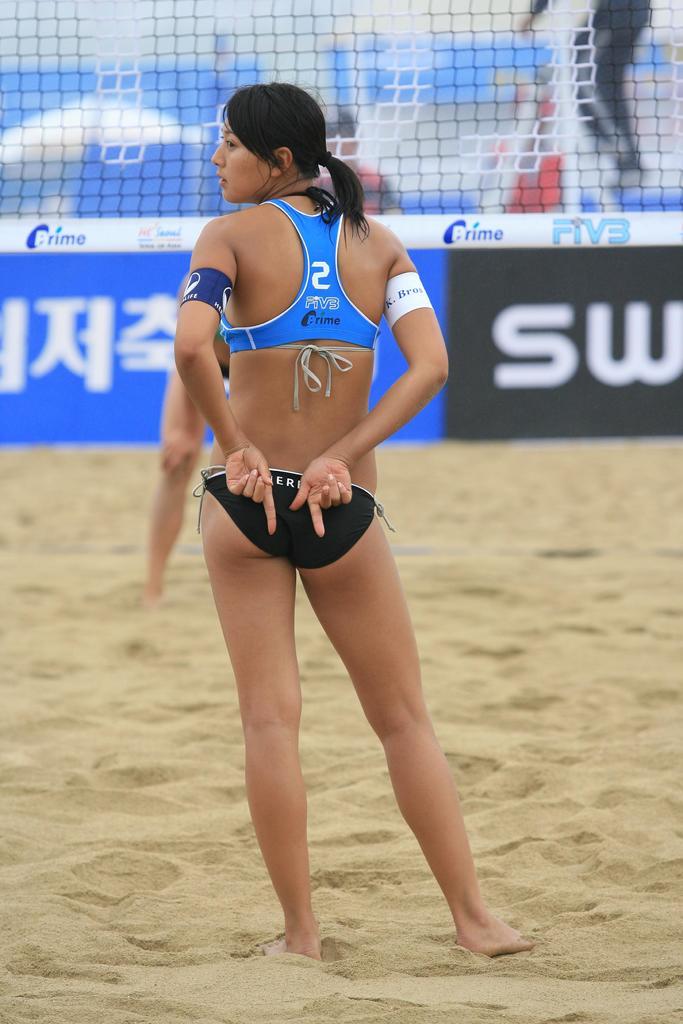What is the number on the girl's shirt?
Ensure brevity in your answer.  2. What is the name of the clothes she is wearing?
Give a very brief answer. Prime. 